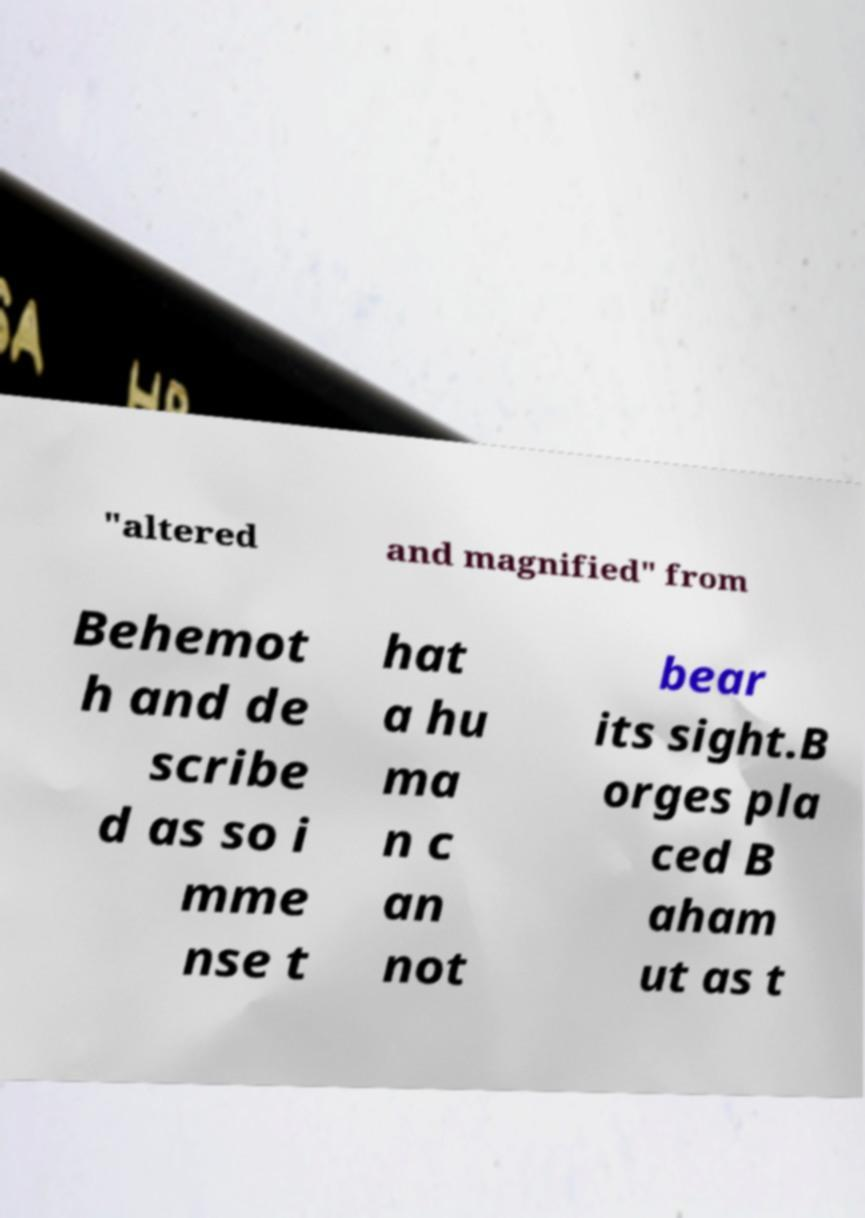For documentation purposes, I need the text within this image transcribed. Could you provide that? "altered and magnified" from Behemot h and de scribe d as so i mme nse t hat a hu ma n c an not bear its sight.B orges pla ced B aham ut as t 